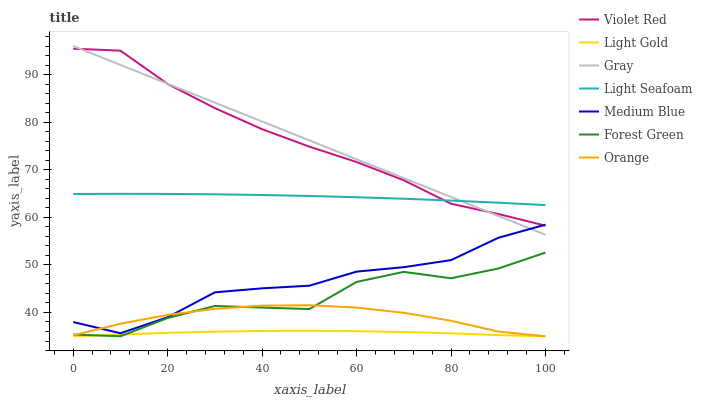Does Light Gold have the minimum area under the curve?
Answer yes or no. Yes. Does Gray have the maximum area under the curve?
Answer yes or no. Yes. Does Violet Red have the minimum area under the curve?
Answer yes or no. No. Does Violet Red have the maximum area under the curve?
Answer yes or no. No. Is Gray the smoothest?
Answer yes or no. Yes. Is Forest Green the roughest?
Answer yes or no. Yes. Is Violet Red the smoothest?
Answer yes or no. No. Is Violet Red the roughest?
Answer yes or no. No. Does Forest Green have the lowest value?
Answer yes or no. Yes. Does Violet Red have the lowest value?
Answer yes or no. No. Does Gray have the highest value?
Answer yes or no. Yes. Does Violet Red have the highest value?
Answer yes or no. No. Is Forest Green less than Violet Red?
Answer yes or no. Yes. Is Light Seafoam greater than Medium Blue?
Answer yes or no. Yes. Does Gray intersect Medium Blue?
Answer yes or no. Yes. Is Gray less than Medium Blue?
Answer yes or no. No. Is Gray greater than Medium Blue?
Answer yes or no. No. Does Forest Green intersect Violet Red?
Answer yes or no. No. 